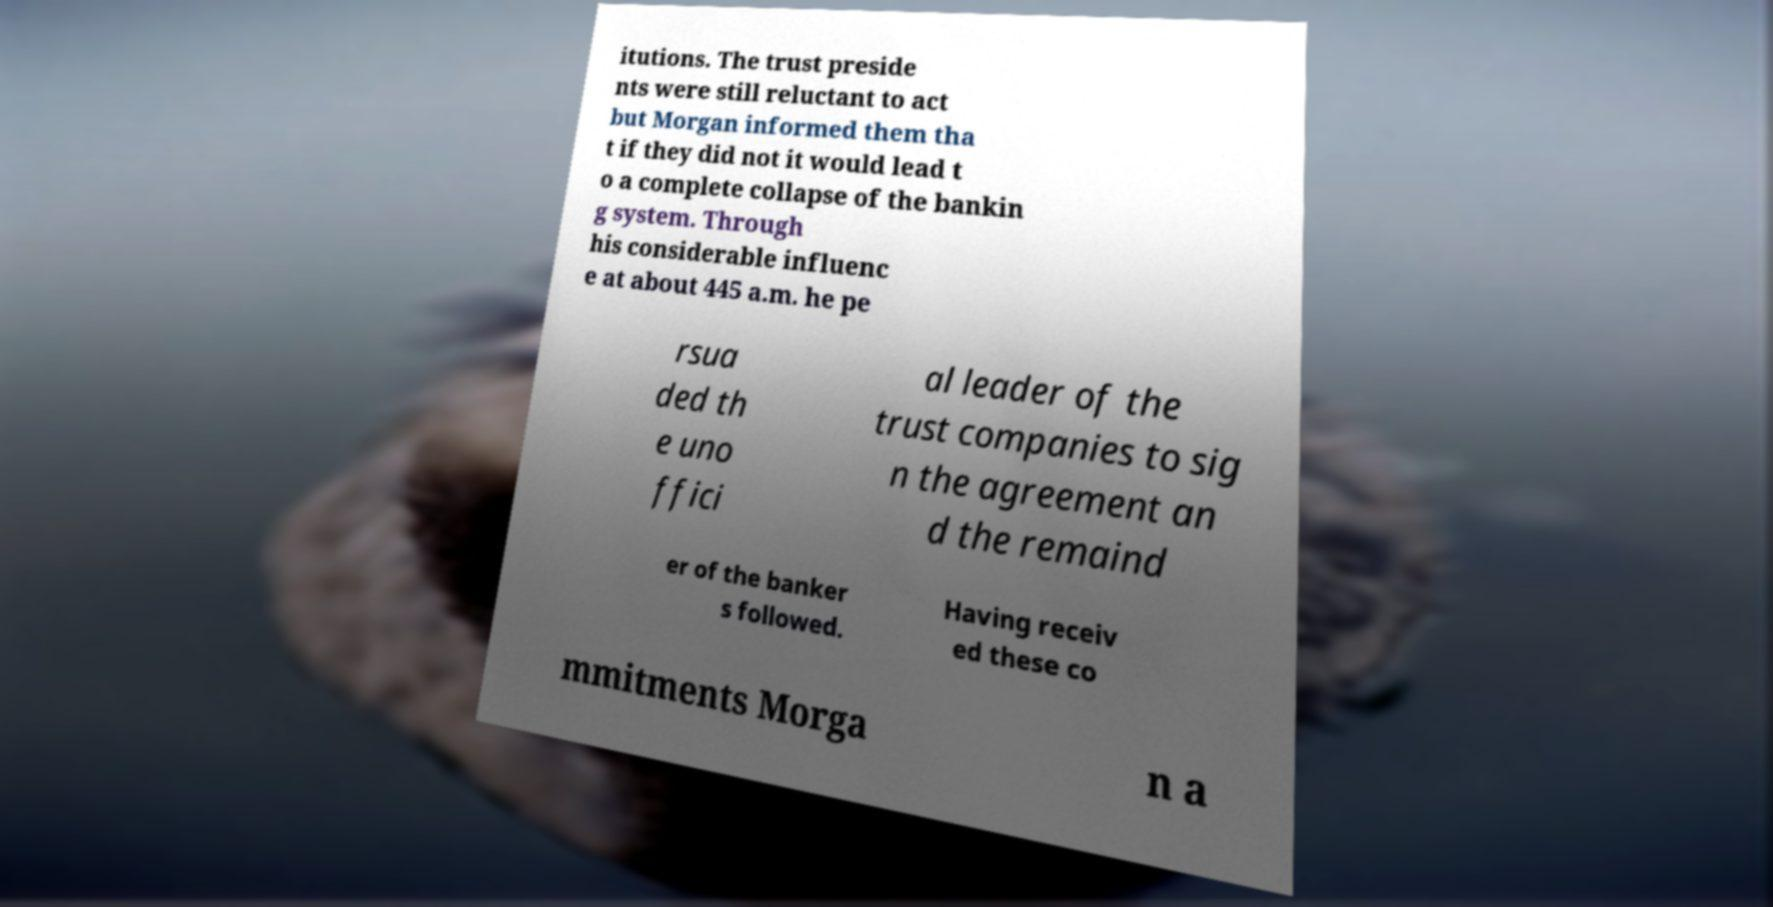Can you accurately transcribe the text from the provided image for me? itutions. The trust preside nts were still reluctant to act but Morgan informed them tha t if they did not it would lead t o a complete collapse of the bankin g system. Through his considerable influenc e at about 445 a.m. he pe rsua ded th e uno ffici al leader of the trust companies to sig n the agreement an d the remaind er of the banker s followed. Having receiv ed these co mmitments Morga n a 